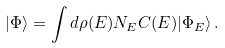<formula> <loc_0><loc_0><loc_500><loc_500>| \Phi \rangle = \int d \rho ( E ) N _ { E } C ( E ) | \Phi _ { E } \rangle \, .</formula> 